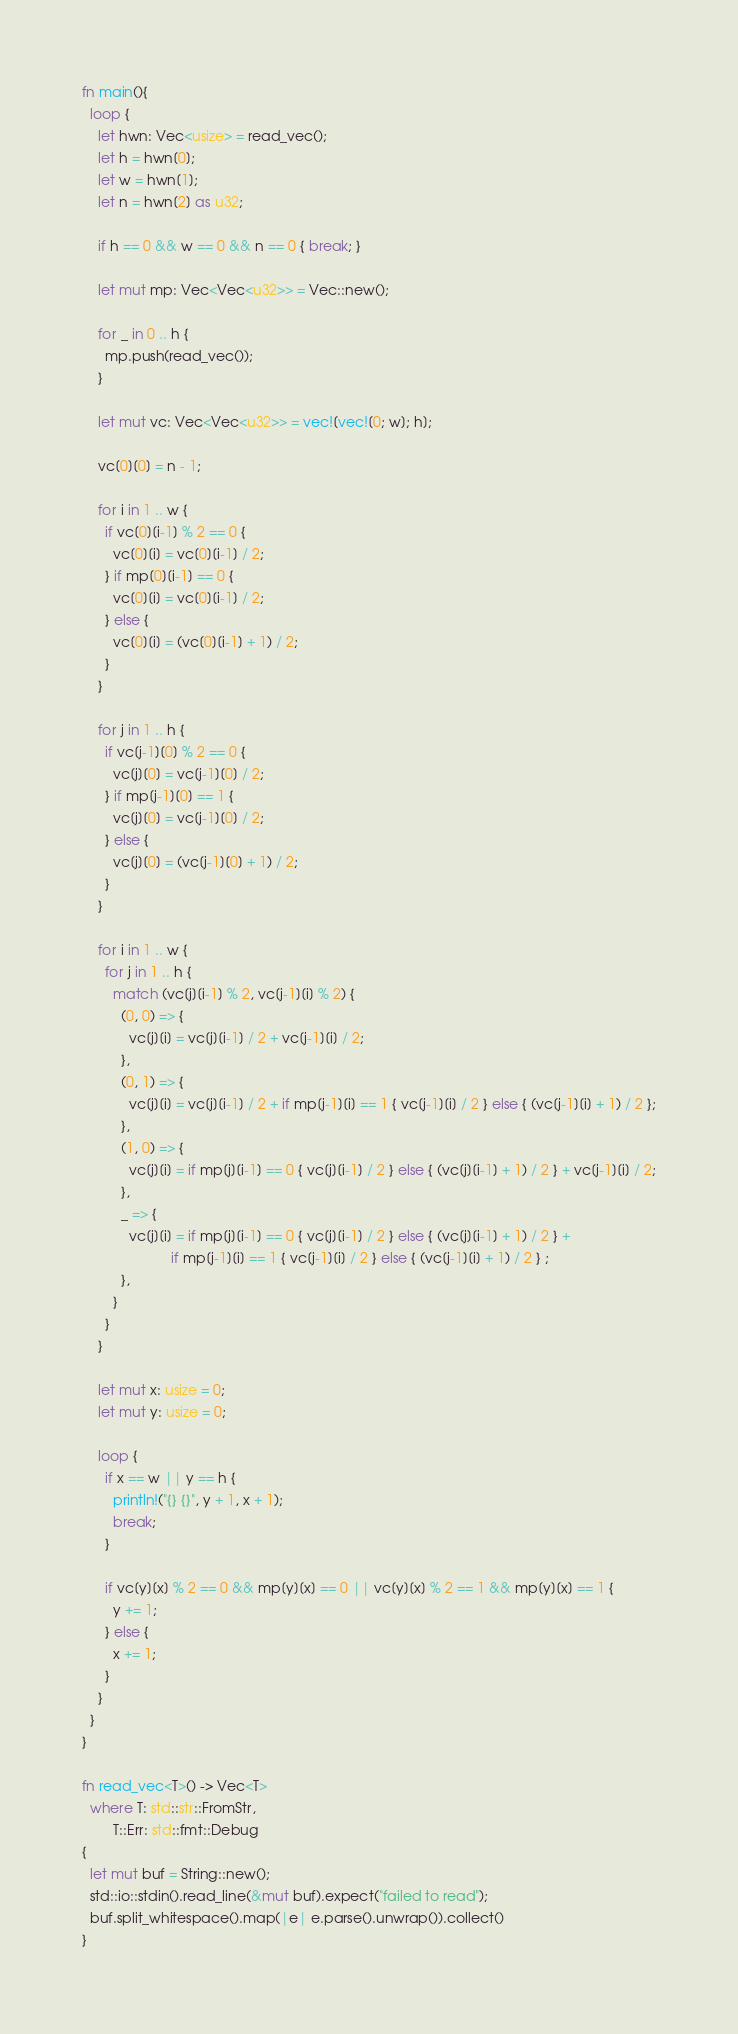Convert code to text. <code><loc_0><loc_0><loc_500><loc_500><_Rust_>fn main(){
  loop {
    let hwn: Vec<usize> = read_vec();
    let h = hwn[0];
    let w = hwn[1];
    let n = hwn[2] as u32;

    if h == 0 && w == 0 && n == 0 { break; }
  
    let mut mp: Vec<Vec<u32>> = Vec::new();
  
    for _ in 0 .. h {
      mp.push(read_vec());
    }

    let mut vc: Vec<Vec<u32>> = vec![vec![0; w]; h];

    vc[0][0] = n - 1;

    for i in 1 .. w {
      if vc[0][i-1] % 2 == 0 {
        vc[0][i] = vc[0][i-1] / 2;
      } if mp[0][i-1] == 0 {
        vc[0][i] = vc[0][i-1] / 2;
      } else {
        vc[0][i] = (vc[0][i-1] + 1) / 2;
      }
    }

    for j in 1 .. h {
      if vc[j-1][0] % 2 == 0 {
        vc[j][0] = vc[j-1][0] / 2;
      } if mp[j-1][0] == 1 {
        vc[j][0] = vc[j-1][0] / 2;
      } else {
        vc[j][0] = (vc[j-1][0] + 1) / 2;
      }
    }
    
    for i in 1 .. w {
      for j in 1 .. h {
        match (vc[j][i-1] % 2, vc[j-1][i] % 2) {
          (0, 0) => {
            vc[j][i] = vc[j][i-1] / 2 + vc[j-1][i] / 2;
          },
          (0, 1) => {
            vc[j][i] = vc[j][i-1] / 2 + if mp[j-1][i] == 1 { vc[j-1][i] / 2 } else { (vc[j-1][i] + 1) / 2 };
          },
          (1, 0) => {
            vc[j][i] = if mp[j][i-1] == 0 { vc[j][i-1] / 2 } else { (vc[j][i-1] + 1) / 2 } + vc[j-1][i] / 2;
          },
          _ => {
            vc[j][i] = if mp[j][i-1] == 0 { vc[j][i-1] / 2 } else { (vc[j][i-1] + 1) / 2 } +
                       if mp[j-1][i] == 1 { vc[j-1][i] / 2 } else { (vc[j-1][i] + 1) / 2 } ;
          },
        }
      }
    }
    
    let mut x: usize = 0;
    let mut y: usize = 0;

    loop {
      if x == w || y == h {
        println!("{} {}", y + 1, x + 1);
        break;
      }

      if vc[y][x] % 2 == 0 && mp[y][x] == 0 || vc[y][x] % 2 == 1 && mp[y][x] == 1 {
        y += 1;
      } else {
        x += 1;
      }
    }
  }
}

fn read_vec<T>() -> Vec<T>
  where T: std::str::FromStr,
        T::Err: std::fmt::Debug
{
  let mut buf = String::new();
  std::io::stdin().read_line(&mut buf).expect("failed to read");
  buf.split_whitespace().map(|e| e.parse().unwrap()).collect()
}

</code> 